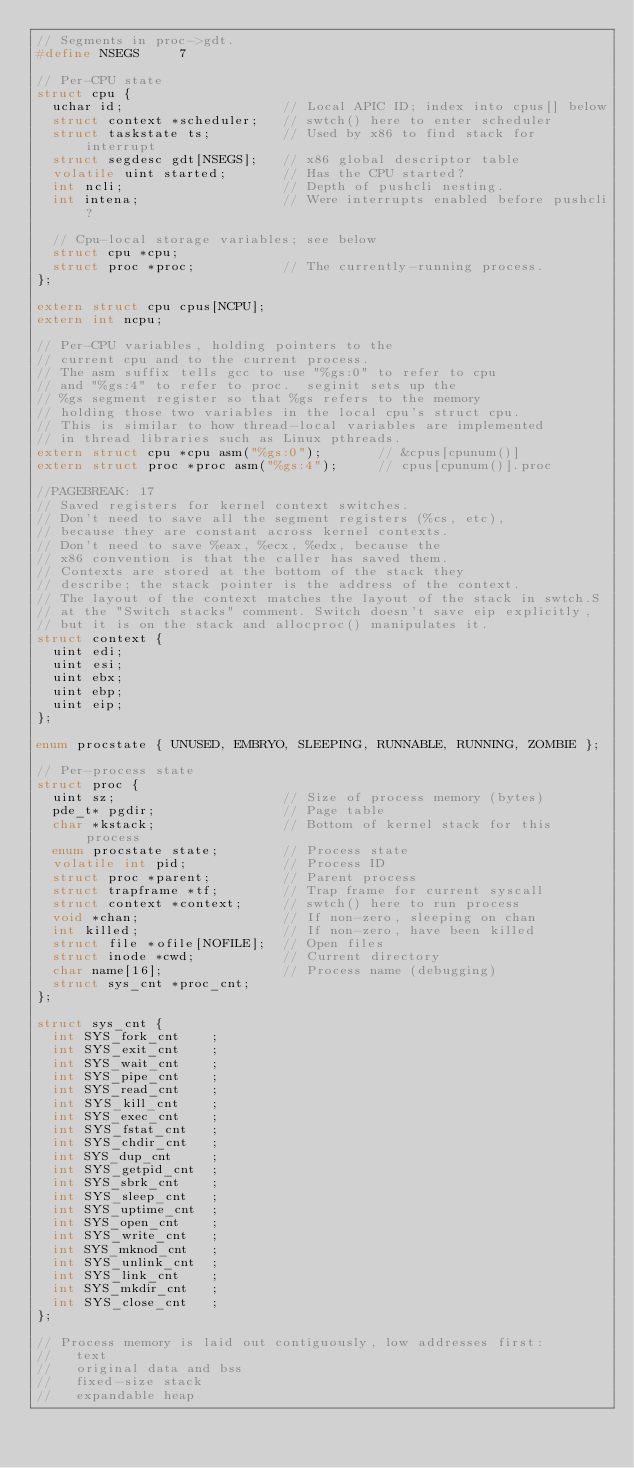Convert code to text. <code><loc_0><loc_0><loc_500><loc_500><_C_>// Segments in proc->gdt.
#define NSEGS     7

// Per-CPU state
struct cpu {
  uchar id;                    // Local APIC ID; index into cpus[] below
  struct context *scheduler;   // swtch() here to enter scheduler
  struct taskstate ts;         // Used by x86 to find stack for interrupt
  struct segdesc gdt[NSEGS];   // x86 global descriptor table
  volatile uint started;       // Has the CPU started?
  int ncli;                    // Depth of pushcli nesting.
  int intena;                  // Were interrupts enabled before pushcli?
  
  // Cpu-local storage variables; see below
  struct cpu *cpu;
  struct proc *proc;           // The currently-running process.
};

extern struct cpu cpus[NCPU];
extern int ncpu;

// Per-CPU variables, holding pointers to the
// current cpu and to the current process.
// The asm suffix tells gcc to use "%gs:0" to refer to cpu
// and "%gs:4" to refer to proc.  seginit sets up the
// %gs segment register so that %gs refers to the memory
// holding those two variables in the local cpu's struct cpu.
// This is similar to how thread-local variables are implemented
// in thread libraries such as Linux pthreads.
extern struct cpu *cpu asm("%gs:0");       // &cpus[cpunum()]
extern struct proc *proc asm("%gs:4");     // cpus[cpunum()].proc

//PAGEBREAK: 17
// Saved registers for kernel context switches.
// Don't need to save all the segment registers (%cs, etc),
// because they are constant across kernel contexts.
// Don't need to save %eax, %ecx, %edx, because the
// x86 convention is that the caller has saved them.
// Contexts are stored at the bottom of the stack they
// describe; the stack pointer is the address of the context.
// The layout of the context matches the layout of the stack in swtch.S
// at the "Switch stacks" comment. Switch doesn't save eip explicitly,
// but it is on the stack and allocproc() manipulates it.
struct context {
  uint edi;
  uint esi;
  uint ebx;
  uint ebp;
  uint eip;
};

enum procstate { UNUSED, EMBRYO, SLEEPING, RUNNABLE, RUNNING, ZOMBIE };

// Per-process state
struct proc {
  uint sz;                     // Size of process memory (bytes)
  pde_t* pgdir;                // Page table
  char *kstack;                // Bottom of kernel stack for this process
  enum procstate state;        // Process state
  volatile int pid;            // Process ID
  struct proc *parent;         // Parent process
  struct trapframe *tf;        // Trap frame for current syscall
  struct context *context;     // swtch() here to run process
  void *chan;                  // If non-zero, sleeping on chan
  int killed;                  // If non-zero, have been killed
  struct file *ofile[NOFILE];  // Open files
  struct inode *cwd;           // Current directory
  char name[16];               // Process name (debugging)
  struct sys_cnt *proc_cnt;
};

struct sys_cnt {
  int SYS_fork_cnt    ;
  int SYS_exit_cnt    ;
  int SYS_wait_cnt    ;
  int SYS_pipe_cnt    ;
  int SYS_read_cnt    ;
  int SYS_kill_cnt    ;
  int SYS_exec_cnt    ;
  int SYS_fstat_cnt   ;
  int SYS_chdir_cnt   ;
  int SYS_dup_cnt     ;
  int SYS_getpid_cnt  ;
  int SYS_sbrk_cnt    ;
  int SYS_sleep_cnt   ;
  int SYS_uptime_cnt  ;
  int SYS_open_cnt    ;
  int SYS_write_cnt   ;
  int SYS_mknod_cnt   ;
  int SYS_unlink_cnt  ;
  int SYS_link_cnt    ;
  int SYS_mkdir_cnt   ;
  int SYS_close_cnt   ;
};

// Process memory is laid out contiguously, low addresses first:
//   text
//   original data and bss
//   fixed-size stack
//   expandable heap
</code> 